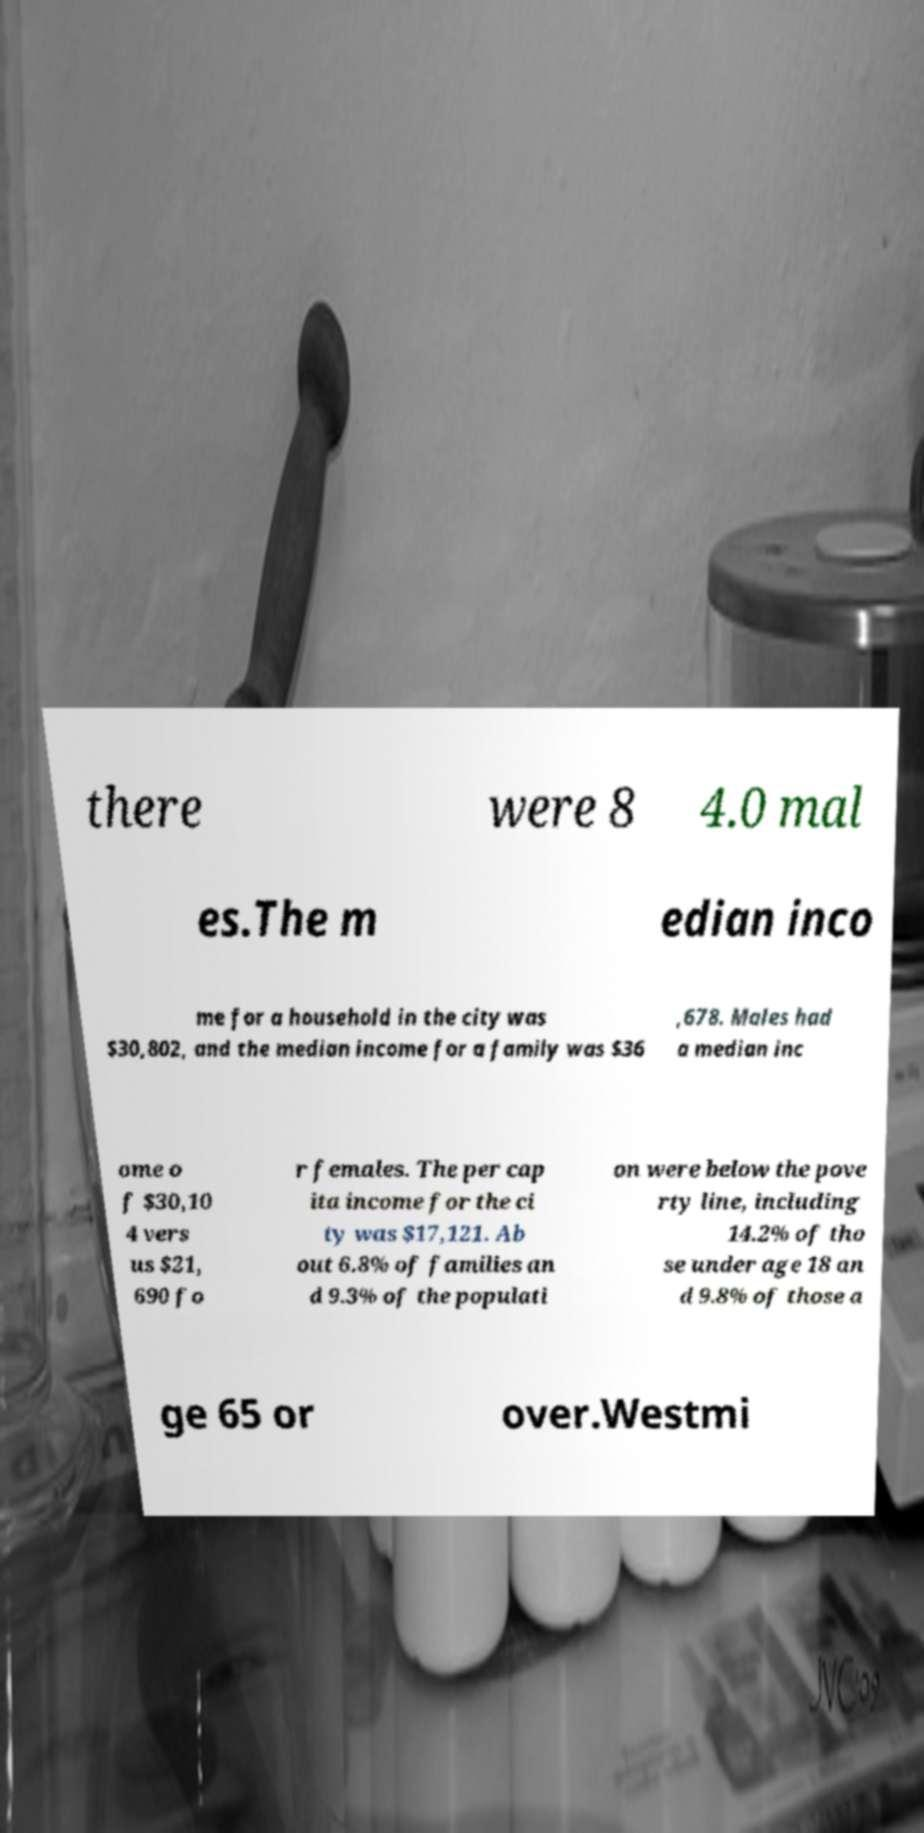I need the written content from this picture converted into text. Can you do that? there were 8 4.0 mal es.The m edian inco me for a household in the city was $30,802, and the median income for a family was $36 ,678. Males had a median inc ome o f $30,10 4 vers us $21, 690 fo r females. The per cap ita income for the ci ty was $17,121. Ab out 6.8% of families an d 9.3% of the populati on were below the pove rty line, including 14.2% of tho se under age 18 an d 9.8% of those a ge 65 or over.Westmi 